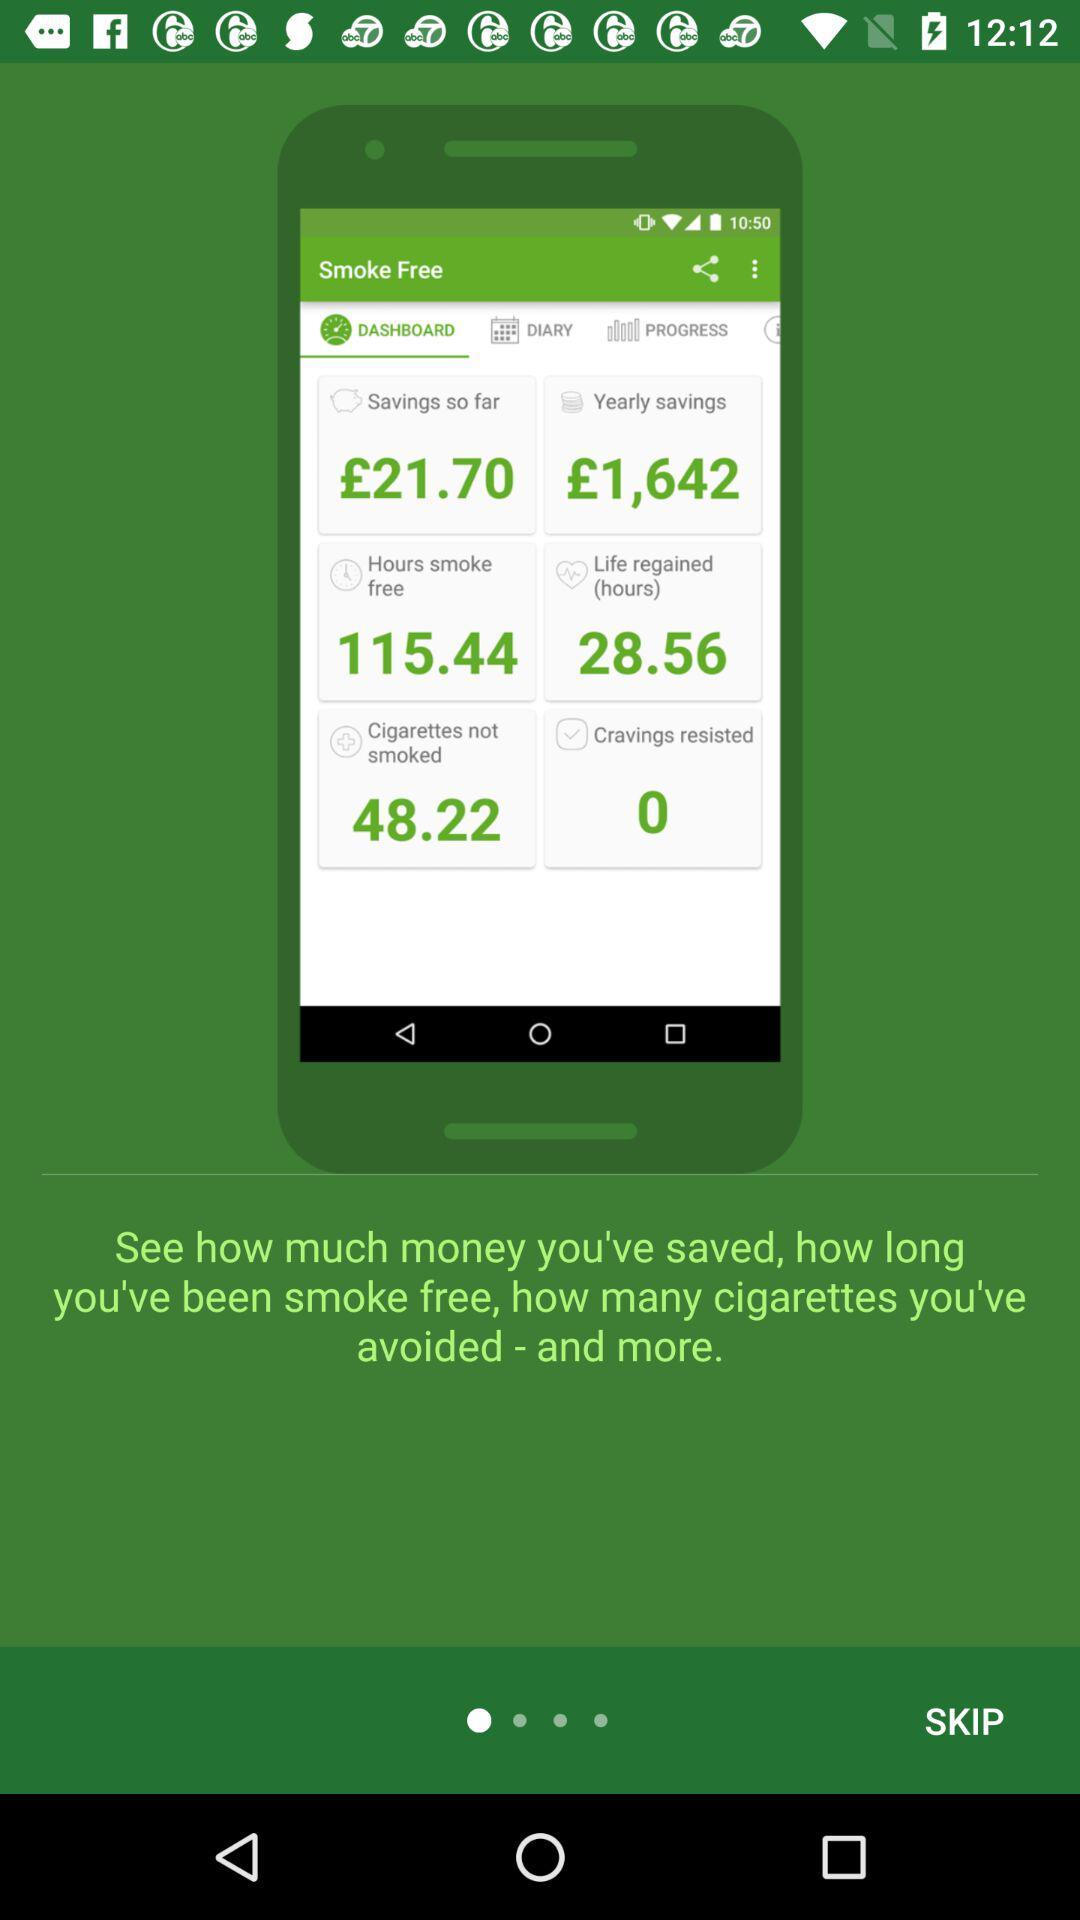What is the yearly savings? The yearly saving is £1,642. 